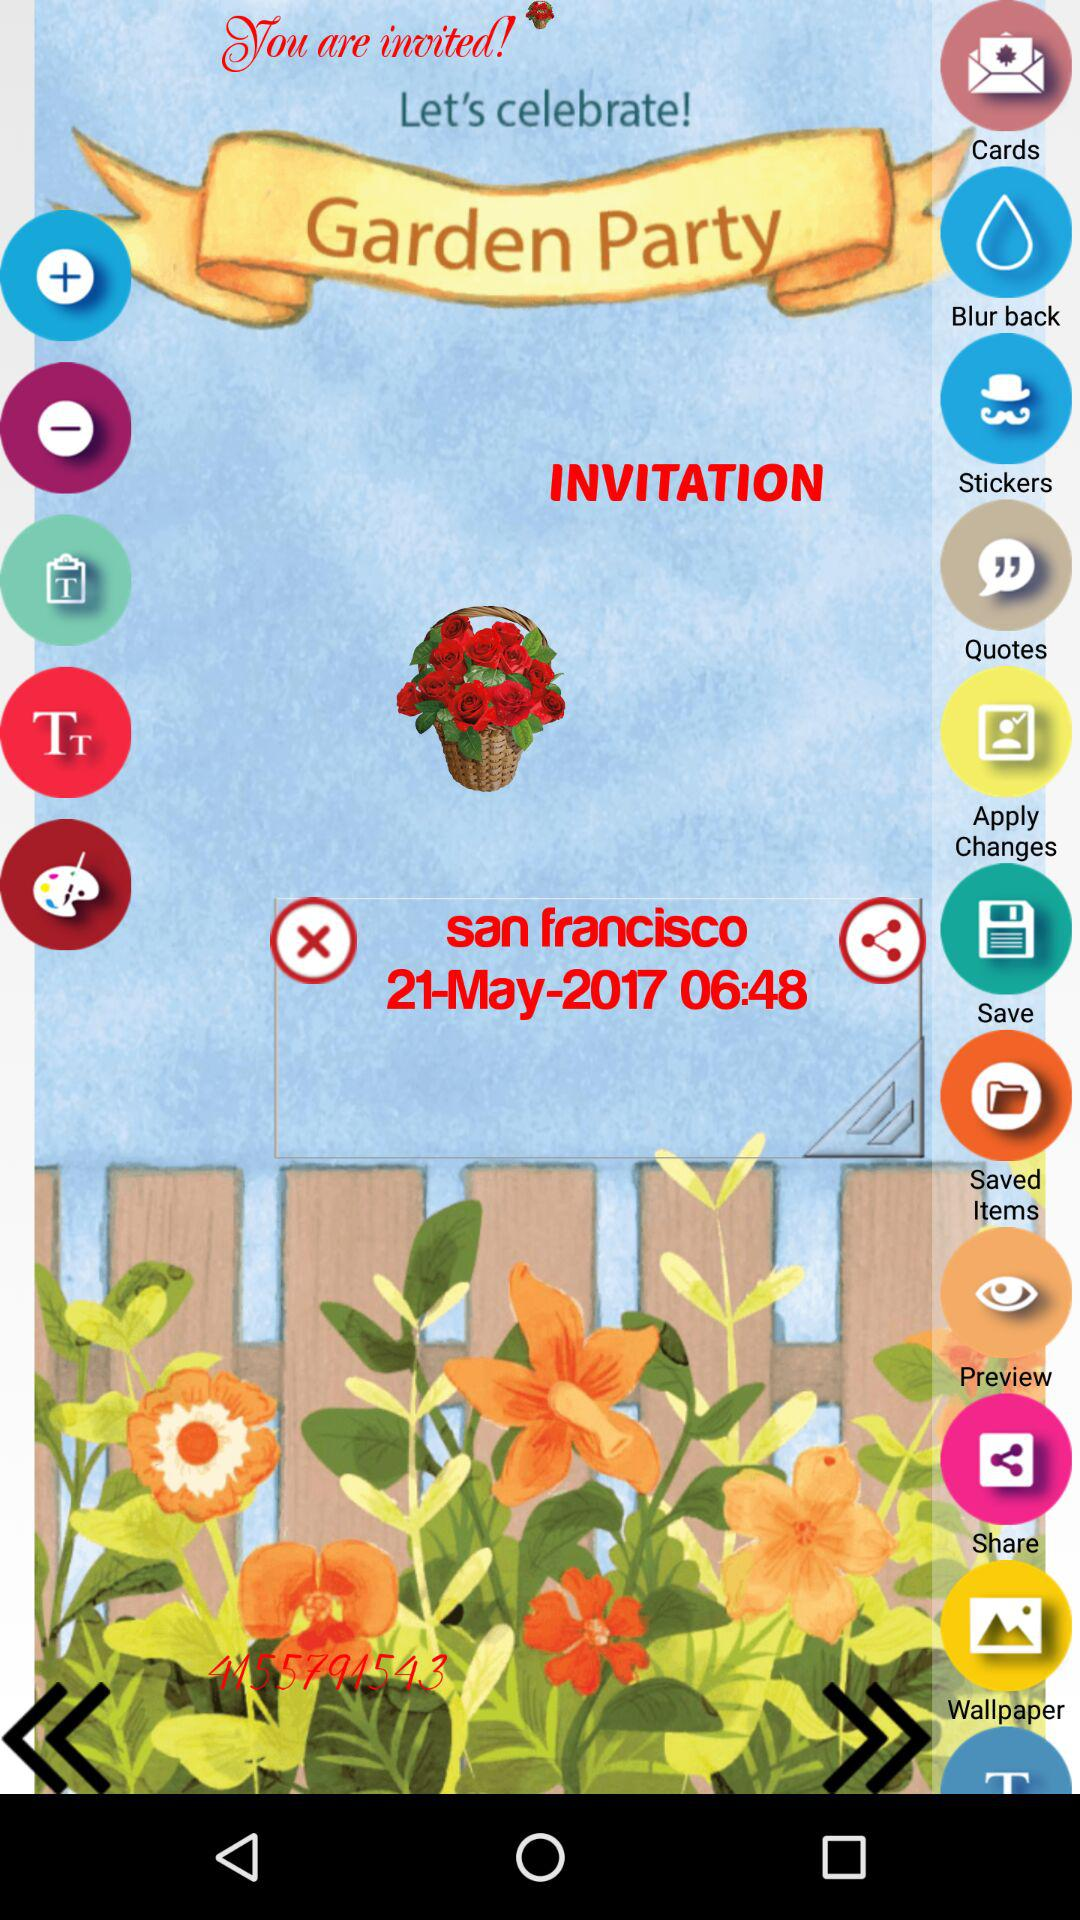What is the location of the party? The location is San Francisco. 